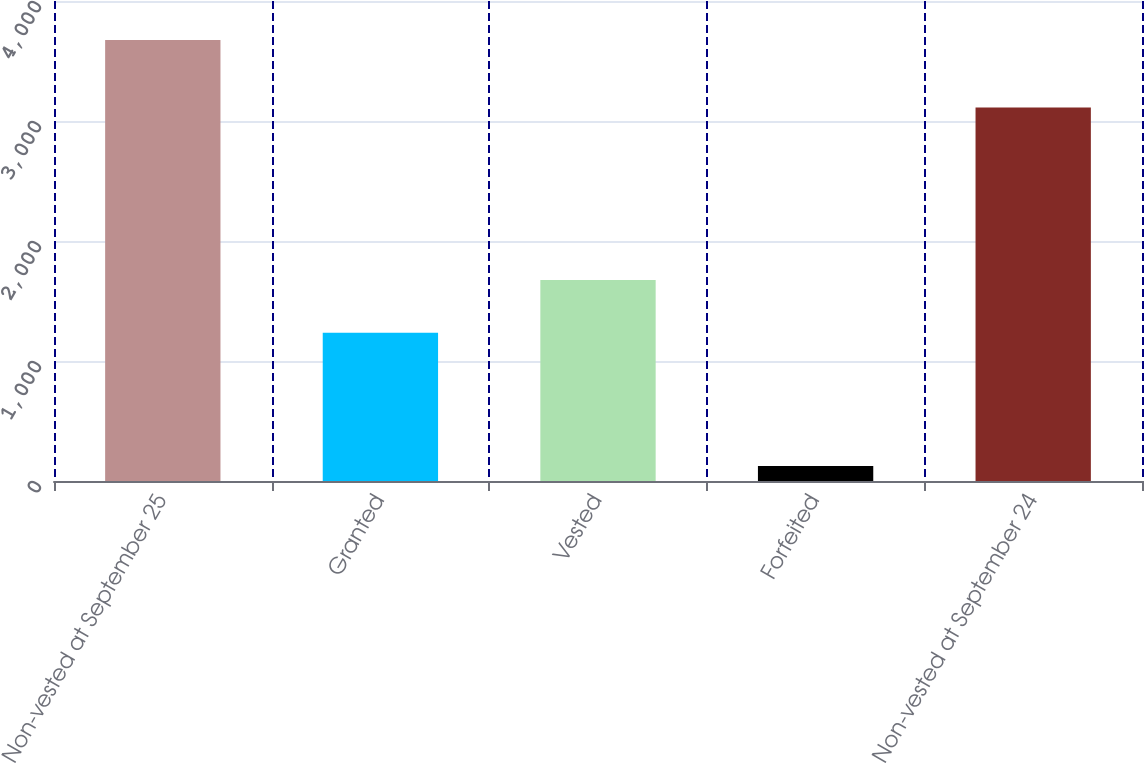<chart> <loc_0><loc_0><loc_500><loc_500><bar_chart><fcel>Non-vested at September 25<fcel>Granted<fcel>Vested<fcel>Forfeited<fcel>Non-vested at September 24<nl><fcel>3676<fcel>1236<fcel>1675<fcel>125<fcel>3112<nl></chart> 